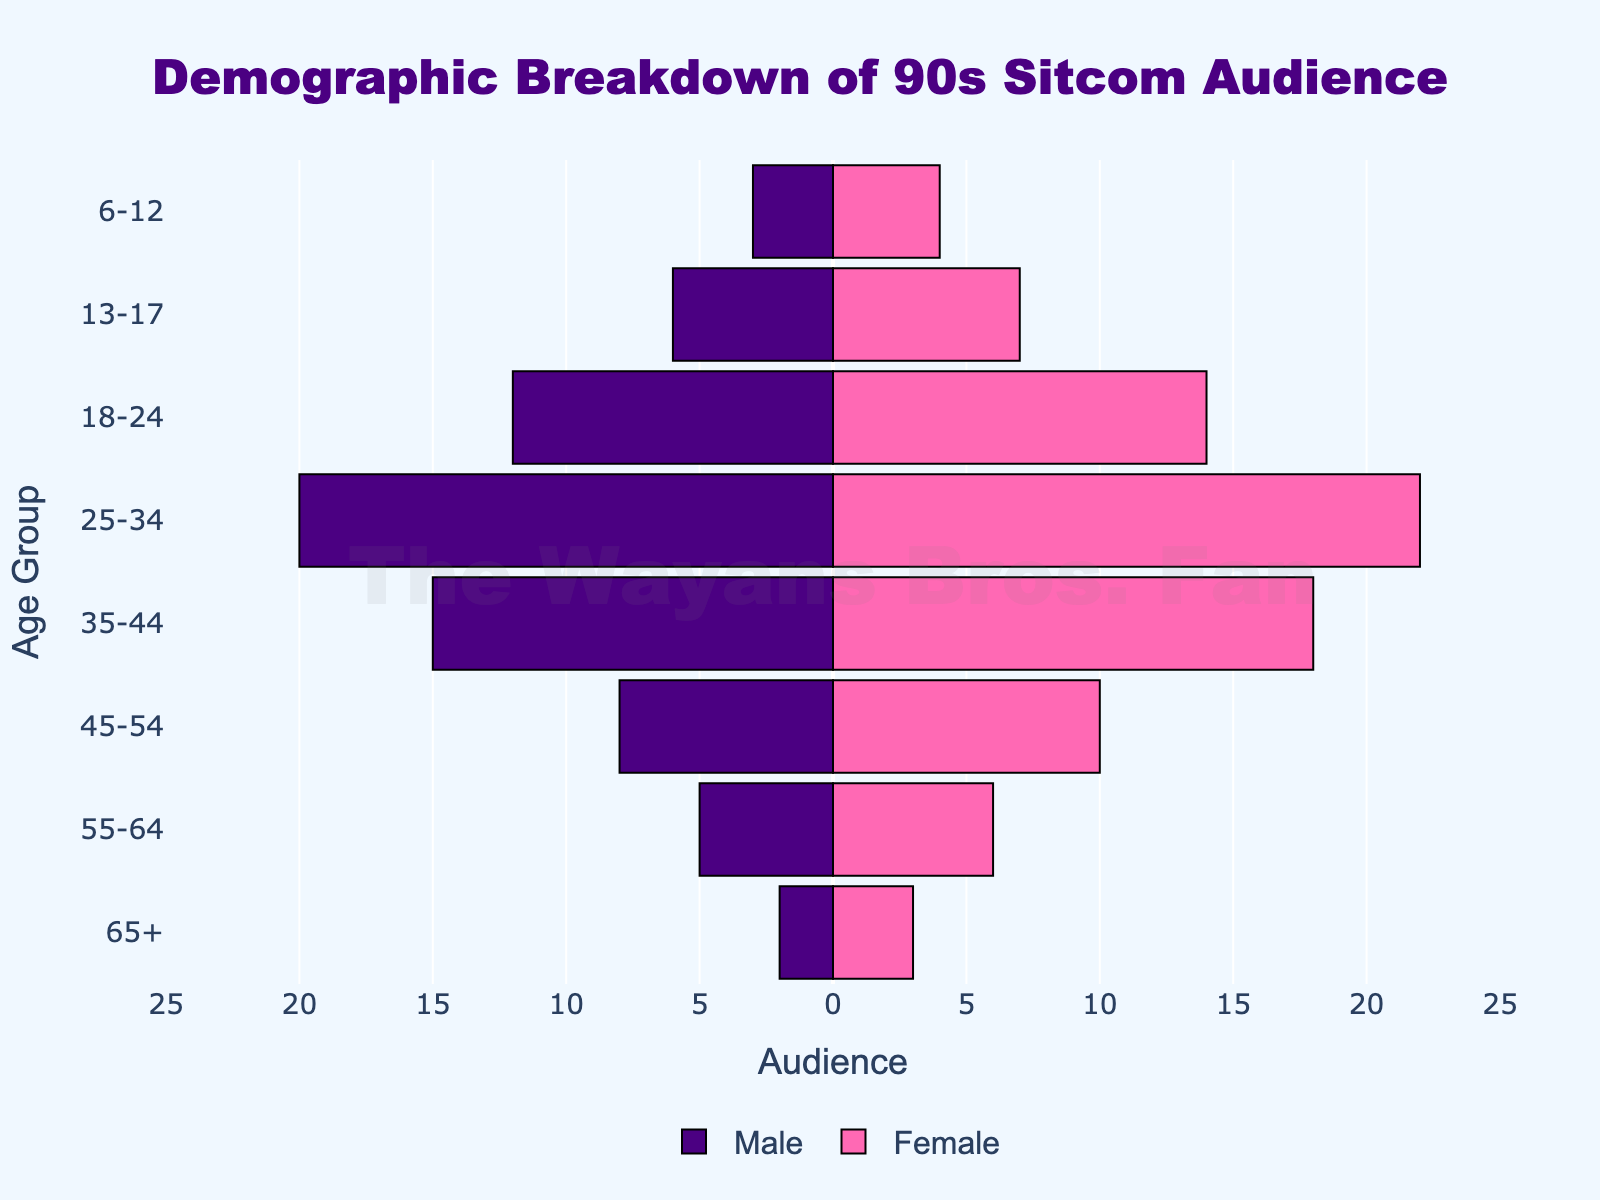what is the title of the chart? The title is located at the top center of the chart. It should be easy to read and is commonly used to give an overview of what the chart is about. Here, the title reads "Demographic Breakdown of 90s Sitcom Audience".
Answer: Demographic Breakdown of 90s Sitcom Audience What are the age groups displayed on the chart? The age groups are listed along the y-axis of the chart. The groups in this chart are "65+", "55-64", "45-54", "35-44", "25-34", "18-24", "13-17", and "6-12".
Answer: 65+, 55-64, 45-54, 35-44, 25-34, 18-24, 13-17, 6-12 What is the color code for male and female bars in the chart? The male bars are colored dark blue (visible as the left side of the pyramid), while the female bars are colored pink (visible as the right side of the pyramid).
Answer: dark blue and pink Which age group has the largest male audience? By observing the size of the bars, the age group "25-34" has the largest male audience with a bar stretching to -20.
Answer: 25-34 Which female audience group is the largest? Looking at the right side of the pyramid, the "25-34" age group has the largest female audience with a bar extending to 22.
Answer: 25-34 Is the number of males or females higher in the "35-44" age group? To answer this, compare the lengths of the male and female bars for the "35-44" group. The female bar extends to 18, while the male bar extends to -15.
Answer: females What is the total audience size for the "18-24" age group? Add the values for males and females in this age group: 12 males + 14 females = 26.
Answer: 26 For the "55-64" age group, what is the difference between the number of males and females? Subtract the number of males from the number of females in this age group: 6 females - 5 males = 1.
Answer: 1 Compare the audience in the "45-54" age group. How many more females are there than males? The number of females in this age group is 10, and the males are 8. Thus, the difference is 10 - 8 = 2.
Answer: 2 Which age group contains the lowest total number of audience members? Sum up the values for each age group and compare. "65+" has a total of 2 males + 3 females = 5, which is the lowest sum compared to other groups.
Answer: 65+ 